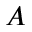<formula> <loc_0><loc_0><loc_500><loc_500>A</formula> 